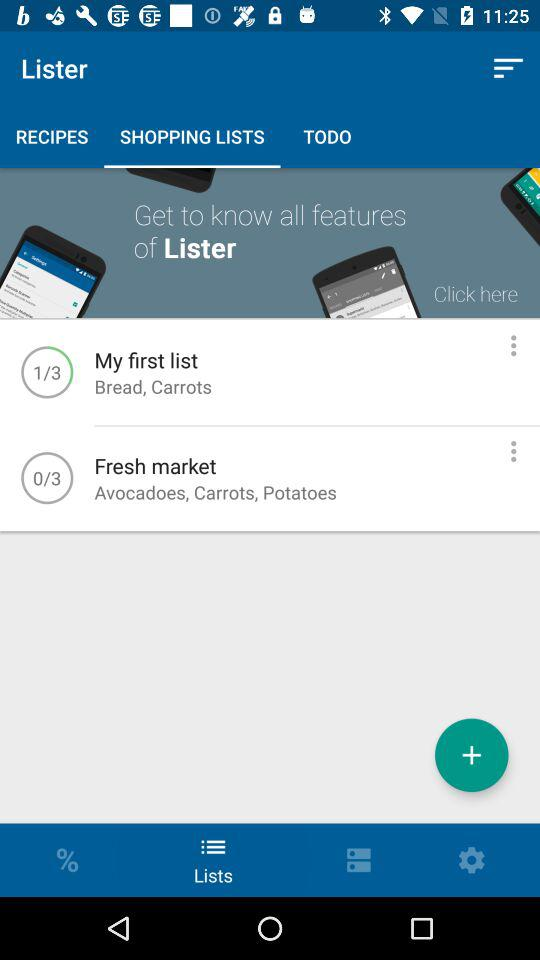What does "Fresh market" include? The fresh market includes "Avocadoes", "Carrots" and "Potatoes". 